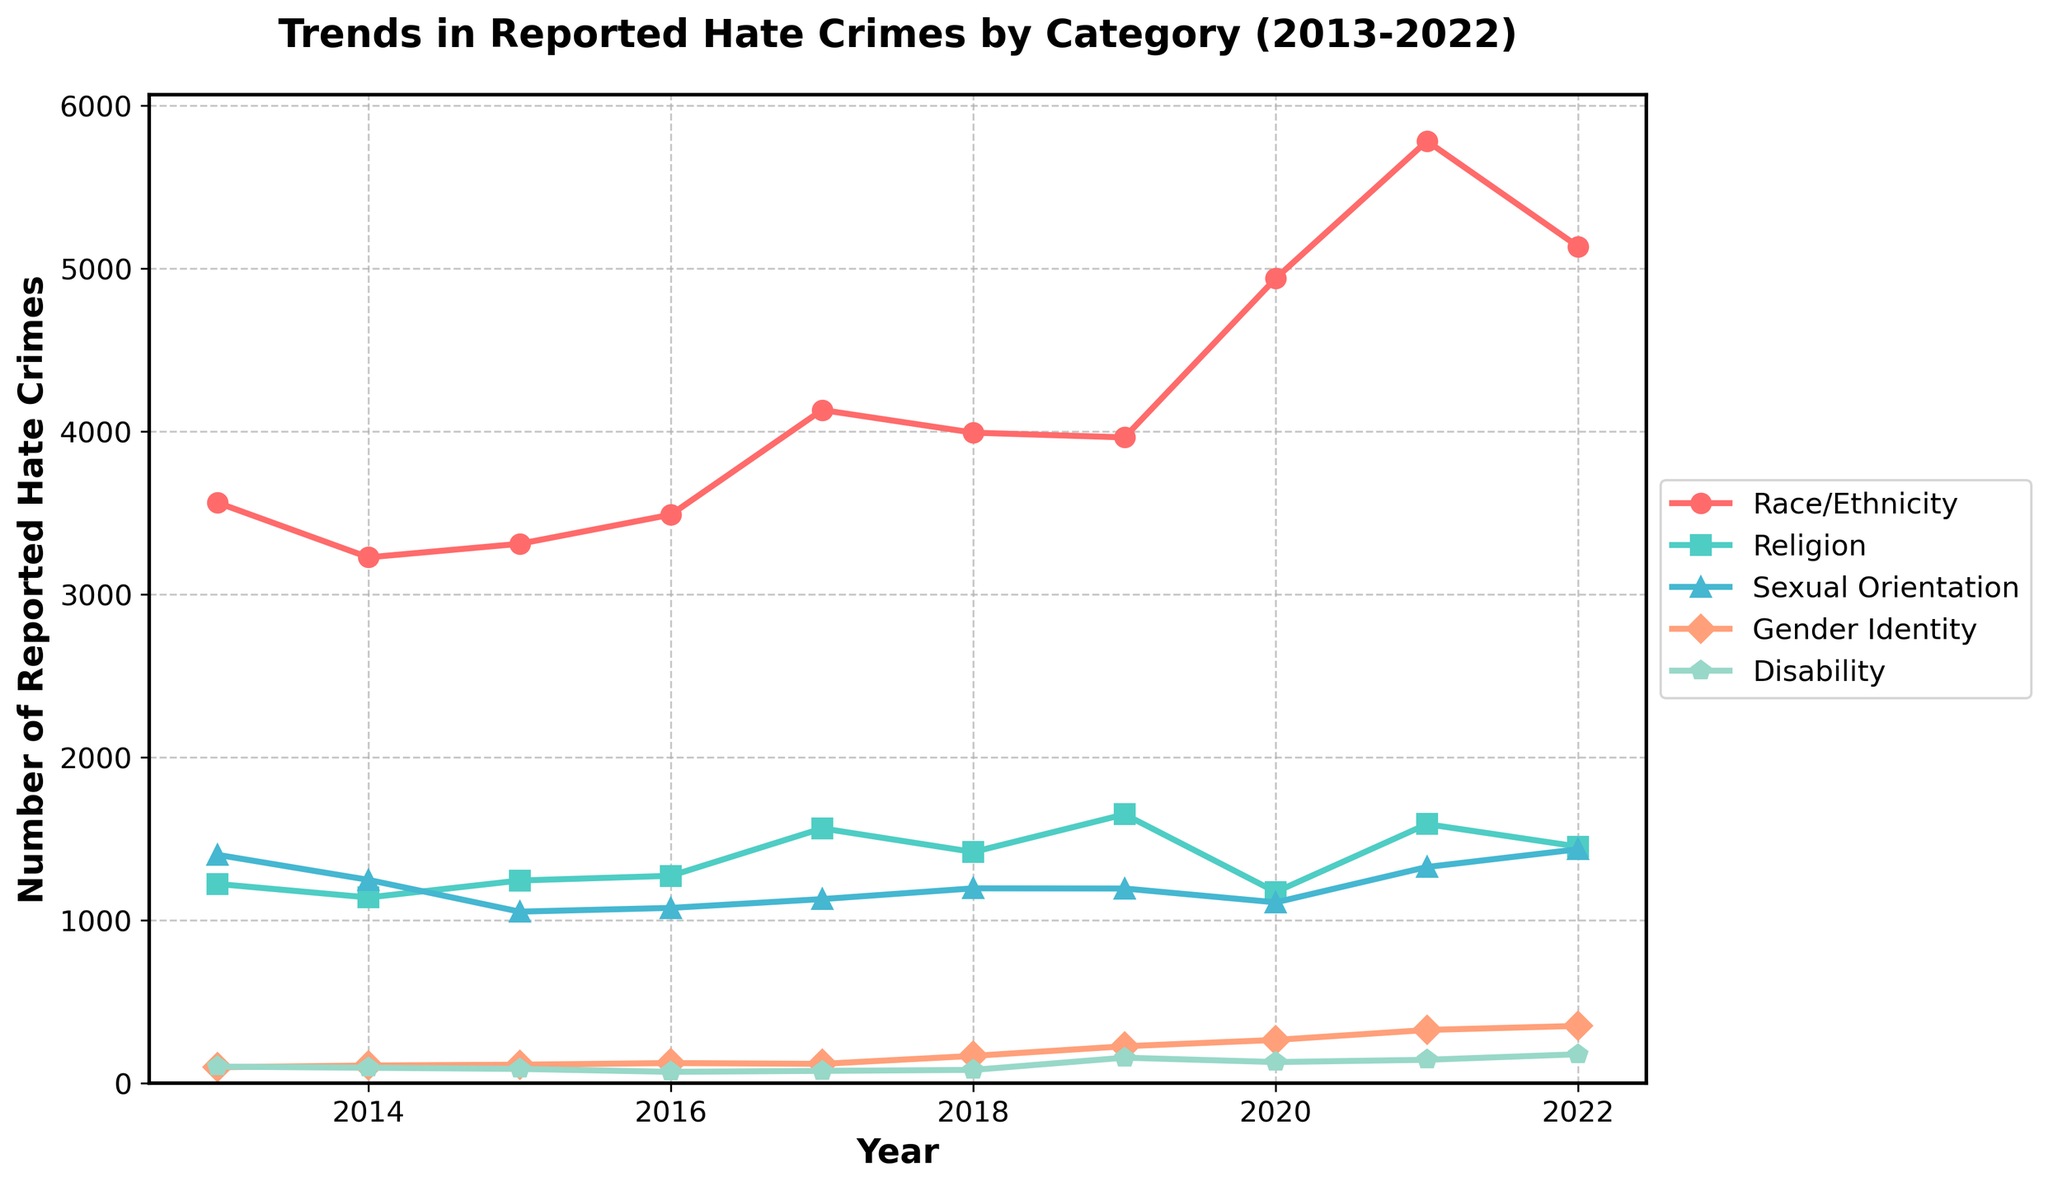What year recorded the highest number of reported hate crimes based on Race/Ethnicity? To determine the year with the highest number of hate crimes based on Race/Ethnicity, follow the line corresponding to Race/Ethnicity and find the year with the peak value. The peak is at 2021 with 5781 reported incidents.
Answer: 2021 Which category of hate crime saw the highest increase in reported incidents from 2019 to 2022? To identify the category with the highest increase, subtract the values of 2019 from 2022 for each category. Calculate: Race/Ethnicity (5134-3963 = 1171), Religion (1452-1650 = -198), Sexual Orientation (1436-1195 = 241), Gender Identity (352-227 = 125), Disability (178-157 = 21). The largest positive change is in Race/Ethnicity.
Answer: Race/Ethnicity How did the number of reported hate crimes based on Disability change between 2013 and 2022? Subtract the value of 2013 from 2022 for the Disability category: 178 (2022) - 102 (2013).
Answer: 76 Which category had the most consistent (least variable) trend over the past decade? Examine the fluctuations for each category over the years. The Disability category shows the smallest changes year over year, indicating the most consistent trend.
Answer: Disability What is the total number of reported hate crimes for Gender Identity across all years? Sum the values for Gender Identity from 2013 to 2022: 98 + 109 + 114 + 124 + 119 + 168 + 227 + 266 + 327 + 352.
Answer: 1904 In which year did the number of reported hate crimes for Sexual Orientation peak? Identify the peak of the yellow line (representing Sexual Orientation). The peak is in the year 2022 with 1436 reported incidents.
Answer: 2022 How does the total number of reported hate crimes in 2020 compare across all categories combined? Sum the reported hate crimes for all categories in 2020: 4939 (Race/Ethnicity) + 1174 (Religion) + 1110 (Sexual Orientation) + 266 (Gender Identity) + 130 (Disability).
Answer: 7619 By what amount did the reported hate crimes based on Religion decrease from 2019 to 2020? Subtract the values for Religion in 2020 from 2019: 1650 (2019) - 1174 (2020).
Answer: 476 How does the trend for reported hate crimes based on Race/Ethnicity compare to that based on Religion from 2016 to 2021? Compare the slopes of the lines representing Race/Ethnicity and Religion. Race/Ethnicity shows a continuous and sharper rise reaching a peak, while Religion fluctuates with a modest peak in 2019 and stabilizes later.
Answer: Race/Ethnicity rises more sharply What is the average number of reported hate crimes based on Sexual Orientation from 2013 to 2022? Find the average by summing the values of Sexual Orientation from 2013 to 2022 and then dividing by the number of years: (1402+1248+1053+1076+1130+1196+1195+1110+1327+1436)/10.
Answer: 1217.3 